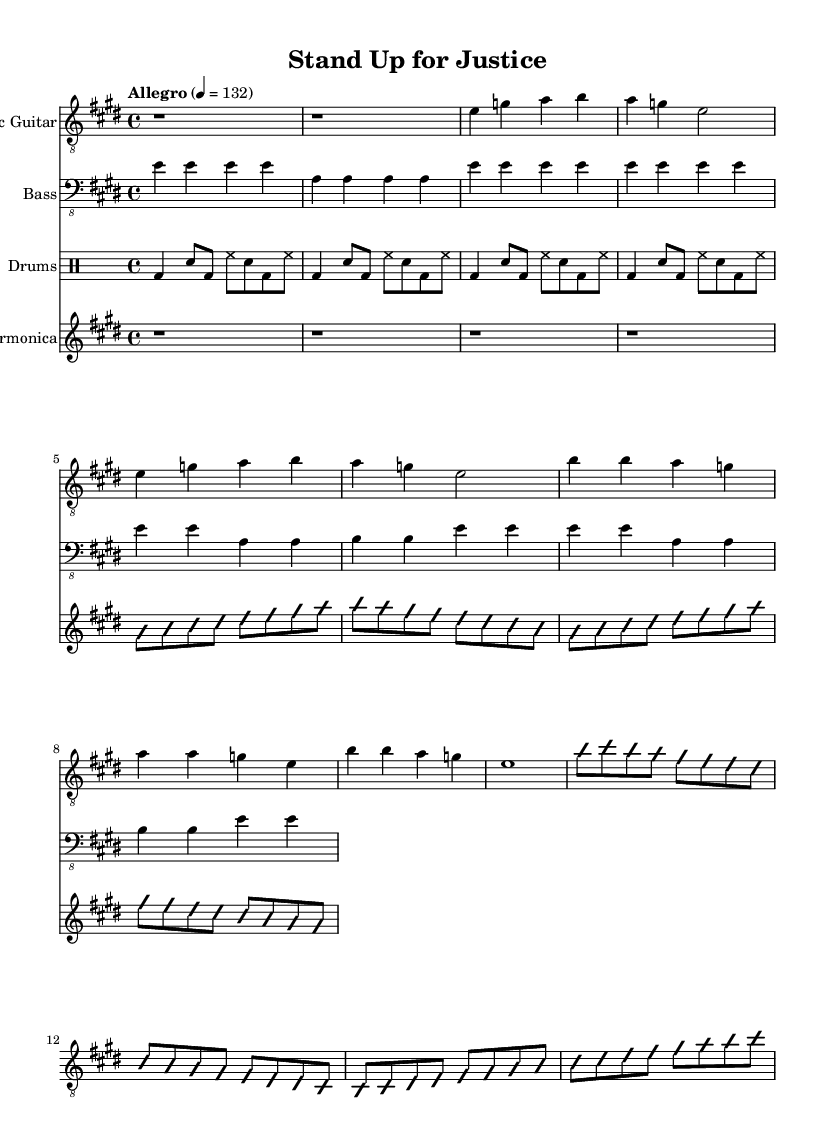What is the key signature of this music? The key signature indicates that the music is in E major, which has four sharps (F#, C#, G#, D#). The presence of the sharp notes in the piece confirms this.
Answer: E major What is the time signature of the piece? The time signature is indicated at the beginning of the sheet music and shows a 4/4 time. This means there are four beats in each measure, and a quarter note receives one beat.
Answer: 4/4 What is the tempo marking for this piece? The tempo marking located at the beginning specifies "Allegro," which indicates a brisk and lively pace. The number indicates that this tempo should be played at 132 beats per minute.
Answer: Allegro How many measures does the guitar solo section have? By counting the measures specifically marked for the guitar solo, I find there are eight measures in total. Each line typically contains four measures, and both guitar solo sections are combined into the guitar staff to provide a clear layout.
Answer: Eight What type of improvisation technique is used in the guitar and harmonica parts? Both the guitar and harmonica parts indicate sections labeled "improvisationOn" and "improvisationOff." This suggests that players are encouraged to improvise between these markers, allowing for expressiveness typical of the Electric Blues style.
Answer: Improvisation What musical elements are typically used to support the theme of social justice and equality in these blues tracks? The piece employs strong emotional expressions found in the lyrics and solos, along with a driving rhythm and call-and-response patterns that are characteristic of Electric Blues. These elements create an impactful musical environment that supports themes of social advocacy.
Answer: Call-and-response 